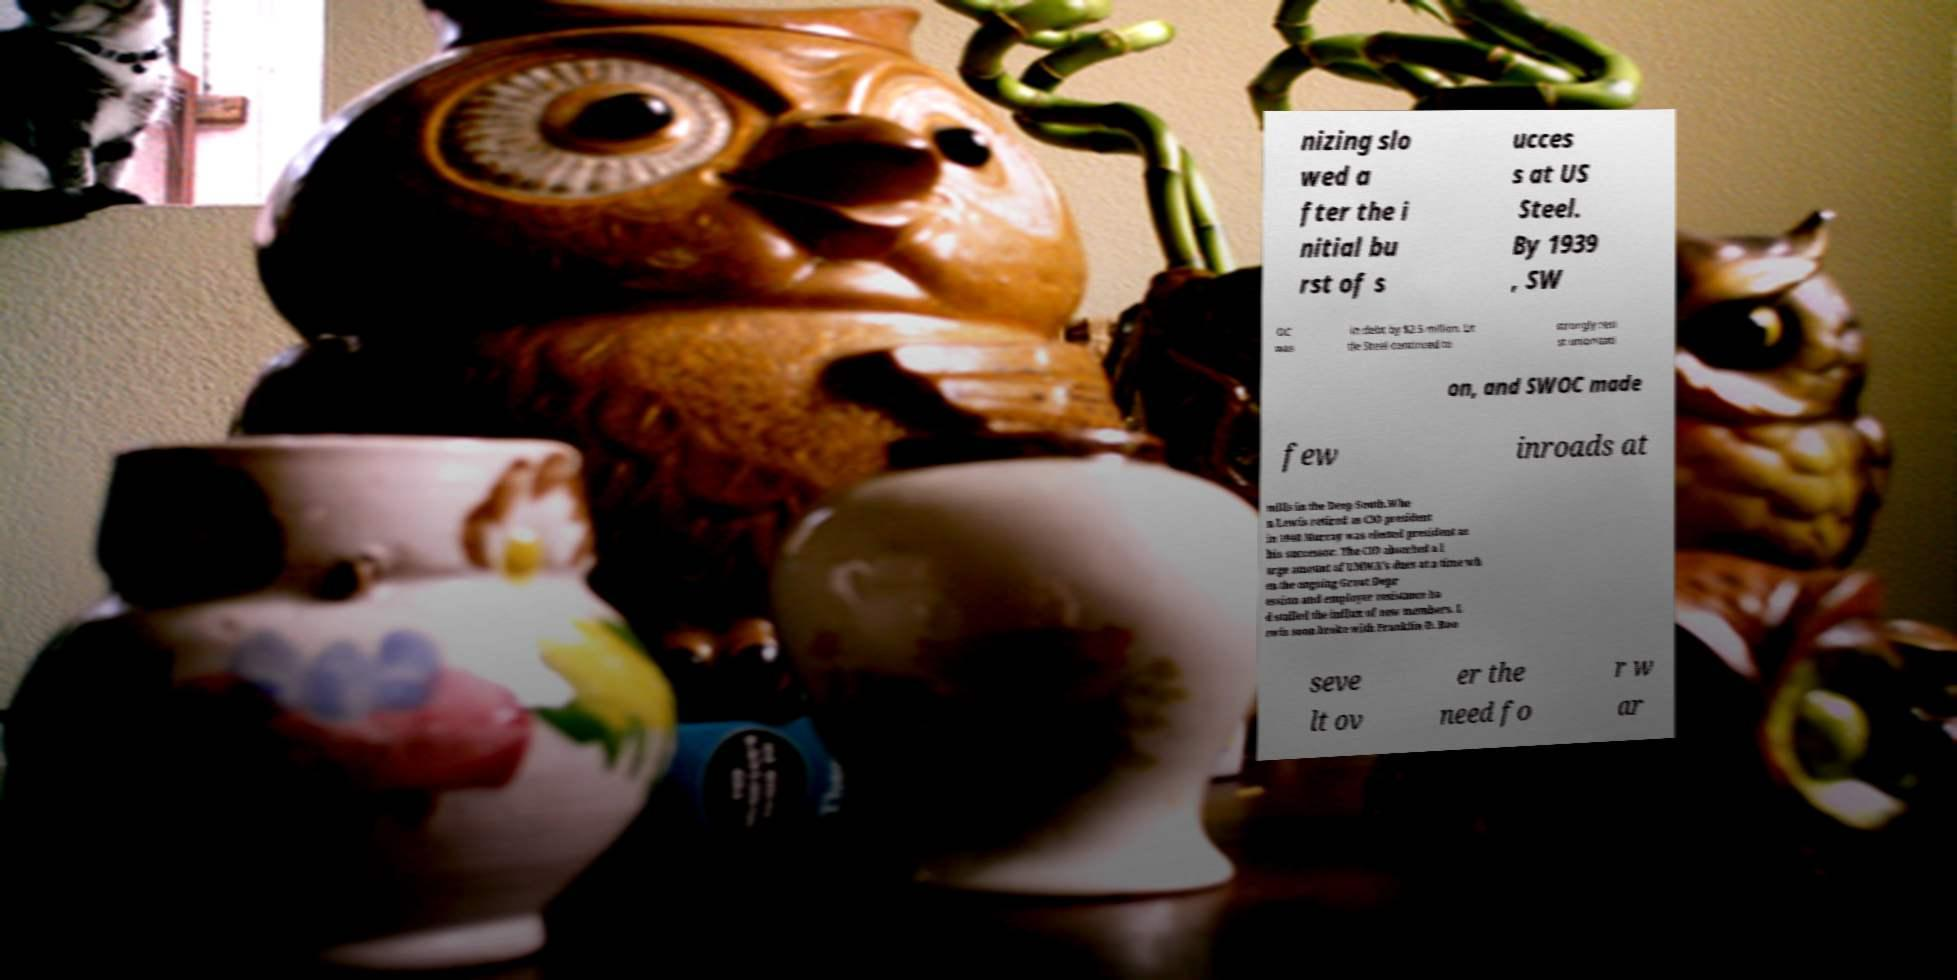Please read and relay the text visible in this image. What does it say? nizing slo wed a fter the i nitial bu rst of s ucces s at US Steel. By 1939 , SW OC was in debt by $2.5 million. Lit tle Steel continued to strongly resi st unionizati on, and SWOC made few inroads at mills in the Deep South.Whe n Lewis retired as CIO president in 1940 Murray was elected president as his successor. The CIO absorbed a l arge amount of UMWA's dues at a time wh en the ongoing Great Depr ession and employer resistance ha d stalled the influx of new members. L ewis soon broke with Franklin D. Roo seve lt ov er the need fo r w ar 